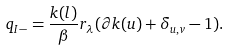Convert formula to latex. <formula><loc_0><loc_0><loc_500><loc_500>q _ { I - } = \frac { k ( l ) } { \beta } r _ { \lambda } ( \partial k ( u ) + \delta _ { u , v } - 1 ) .</formula> 